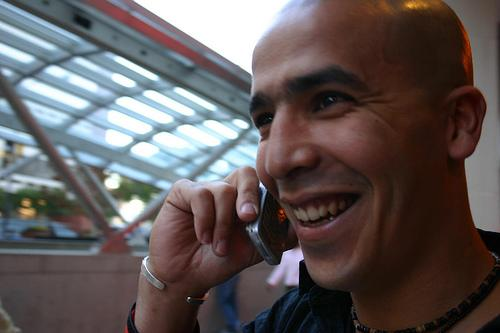Describe the main subject in a humorous or quirky manner and mention their action. A shiny-headed man with dental hygiene on display chats on a shiny silver phone that he's matched to his head. In a colorful and vivid language, depict the main individual and their actions in the image. A man with a dazzlingly bald head radiates with joy and laughter as he engages in a lively conversation on a shiny silver phone. Write a short and straightforward depiction of the main subject in the photo and their action. Bald man holding a phone to his ear, talking and smiling. Describe the main person and their activity in the image with a touch of exaggeration. A man with a perfectly polished bald head is cheerfully talking on a phone, as if catching up with a long-lost friend. Using a metaphor or a creative phrase, describe the primary person in the image and their activity. A man with a head as shiny as a polished gemstone is engaged in a delightful conversation on a silver phone. Provide a simple and direct description of the person and their action taking place in the image. Man with bald head talking on phone, smiling. Provide a brief description of what the main person is wearing and doing in the image. A man wearing a dark-colored shirt, a necklace, and a bracelet, is happily chatting on a cell phone. Create a poetic description of the person and activity taking place in the image. Under skies clear and blue, a man with a bald head smooth and true, speaks softly into a silver device, laughter and joy in his eyes. Mention the most prominent feature of the person and their action in the image. A bald man is talking on a silver cell phone with a big smile. Briefly explain what the main person in the image is doing, including an adjective to describe their expression. An exuberant bald man is engaged in a conversation on a cell phone, revealing his happy smile. 